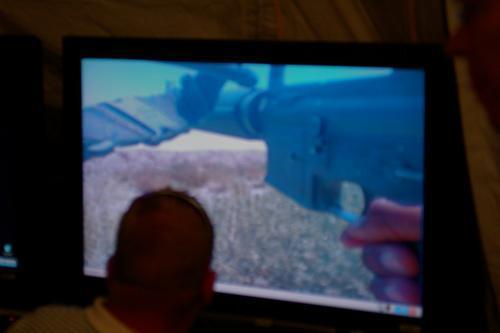How many people are there watching T.V.?
Give a very brief answer. 1. 